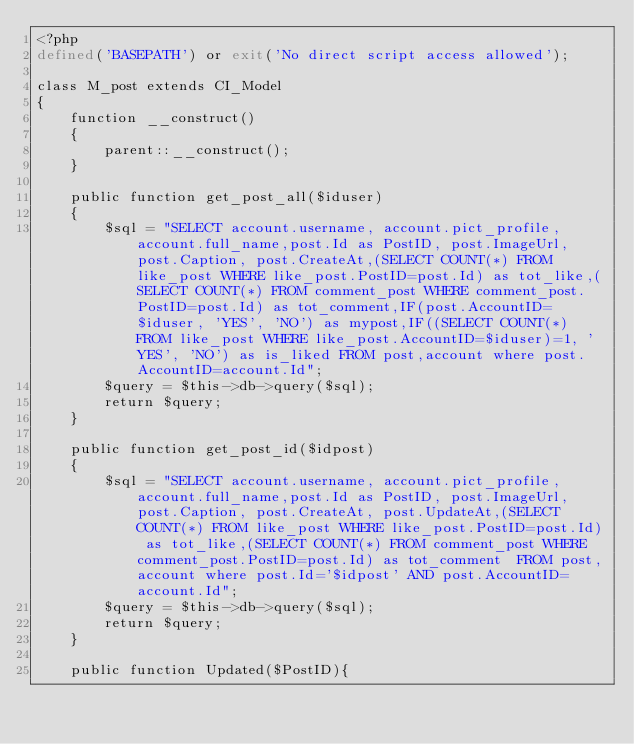<code> <loc_0><loc_0><loc_500><loc_500><_PHP_><?php
defined('BASEPATH') or exit('No direct script access allowed');

class M_post extends CI_Model
{
    function __construct()
    {
        parent::__construct();
    }

    public function get_post_all($iduser)
    {
        $sql = "SELECT account.username, account.pict_profile, account.full_name,post.Id as PostID, post.ImageUrl, post.Caption, post.CreateAt,(SELECT COUNT(*) FROM like_post WHERE like_post.PostID=post.Id) as tot_like,(SELECT COUNT(*) FROM comment_post WHERE comment_post.PostID=post.Id) as tot_comment,IF(post.AccountID=$iduser, 'YES', 'NO') as mypost,IF((SELECT COUNT(*) FROM like_post WHERE like_post.AccountID=$iduser)=1, 'YES', 'NO') as is_liked FROM post,account where post.AccountID=account.Id";
        $query = $this->db->query($sql);
        return $query;
    }

    public function get_post_id($idpost)
    {
        $sql = "SELECT account.username, account.pict_profile, account.full_name,post.Id as PostID, post.ImageUrl, post.Caption, post.CreateAt, post.UpdateAt,(SELECT COUNT(*) FROM like_post WHERE like_post.PostID=post.Id) as tot_like,(SELECT COUNT(*) FROM comment_post WHERE comment_post.PostID=post.Id) as tot_comment  FROM post,account where post.Id='$idpost' AND post.AccountID=account.Id";
        $query = $this->db->query($sql);
        return $query;
    }

    public function Updated($PostID){</code> 